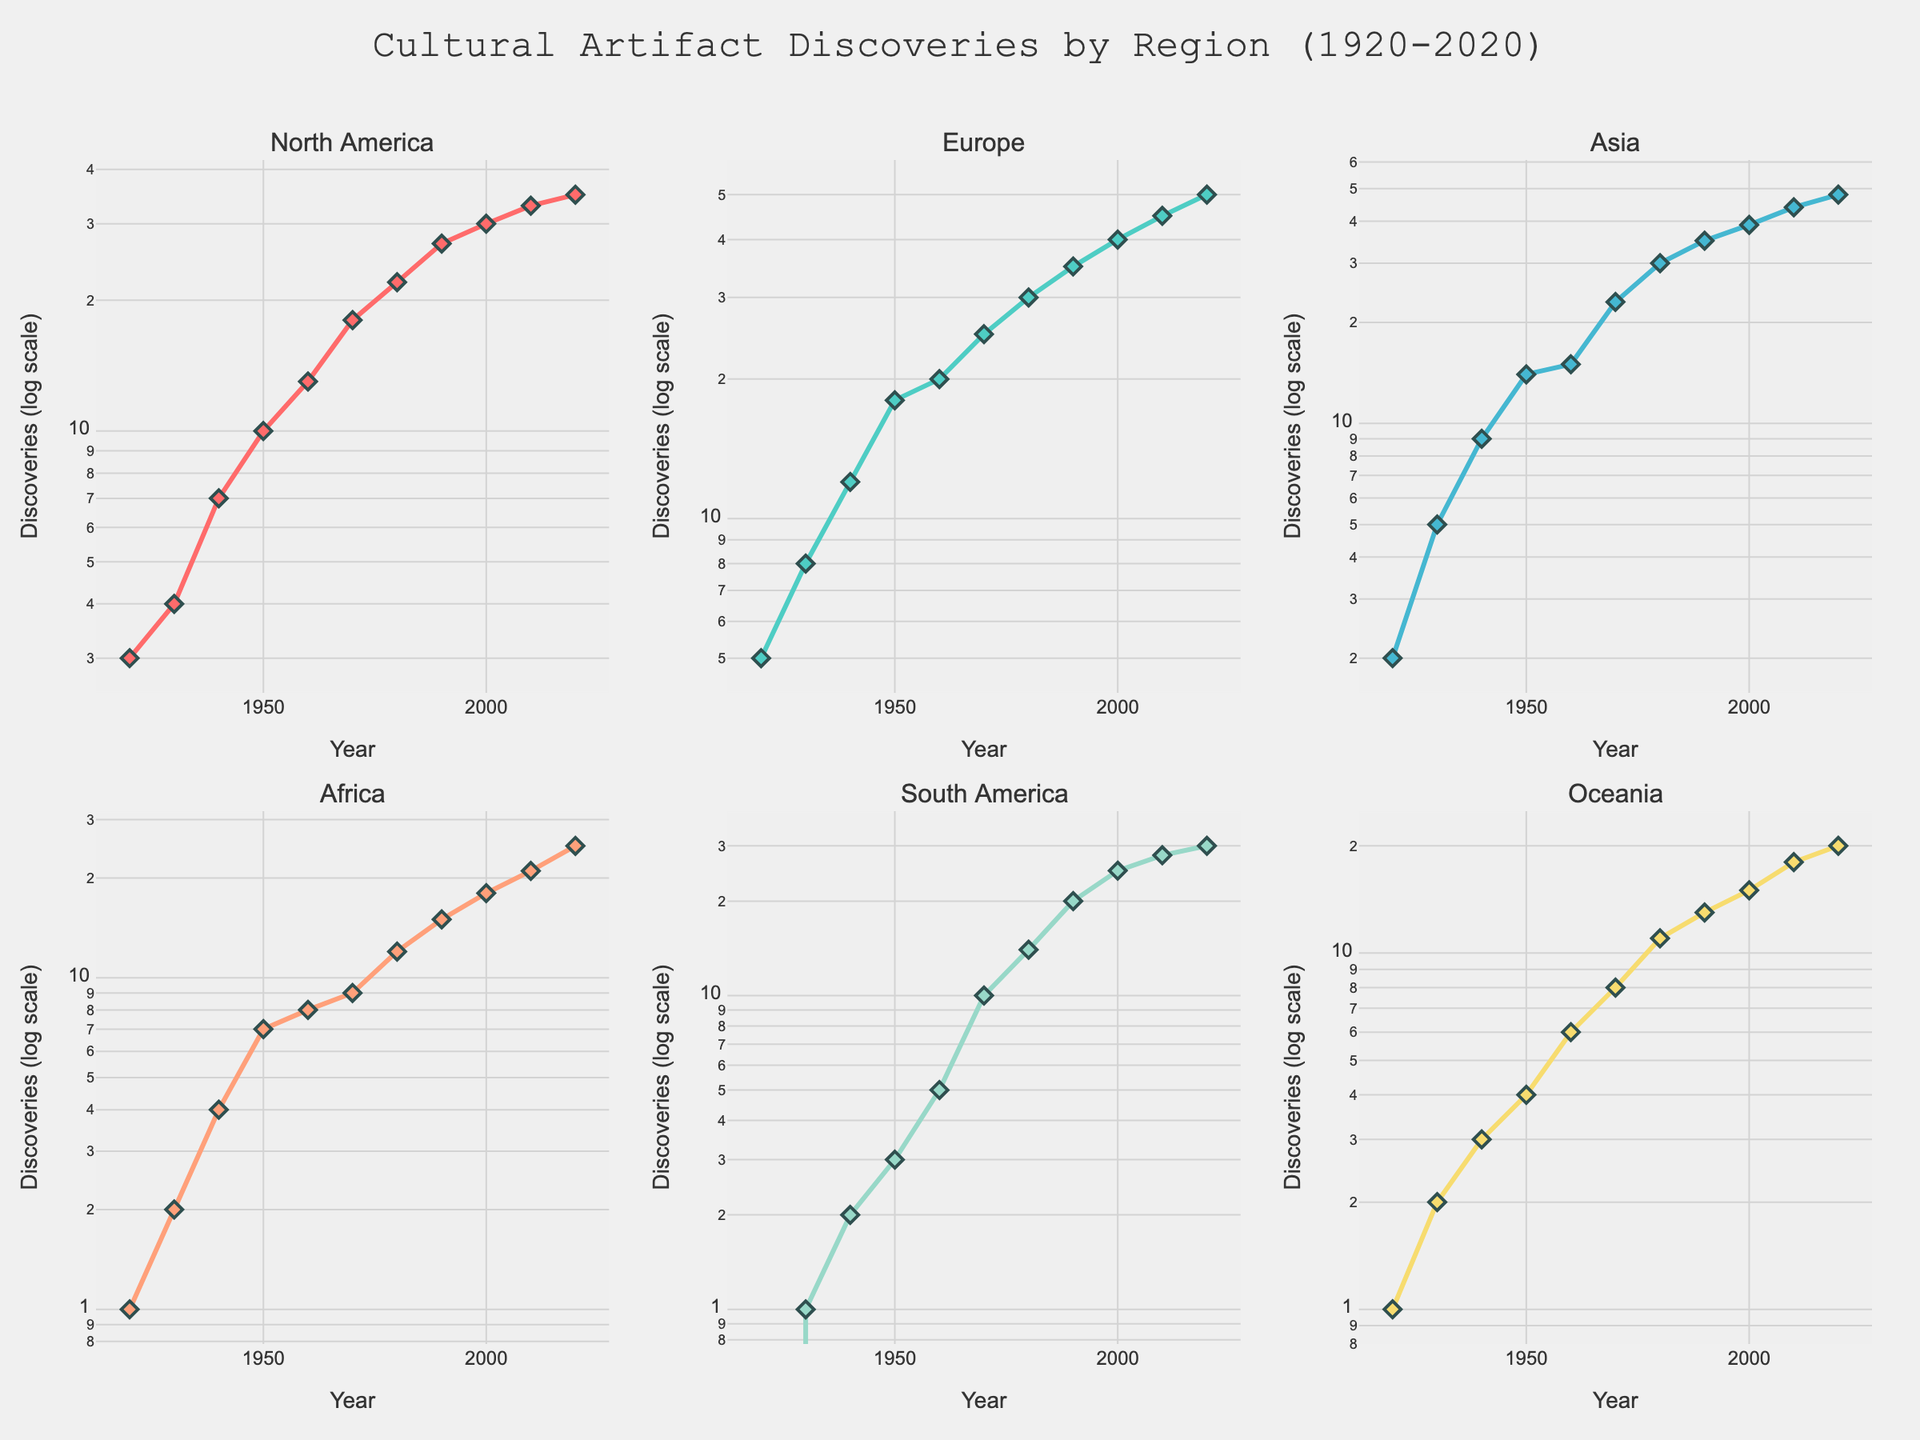Which region has the highest number of discoveries in 2020? Look at the data points for the year 2020 and compare the discovery counts for each region. Europe shows the highest number.
Answer: Europe How many discoveries were made in North America in 1930? Check the 1930 data point for North America in the subplot. The number of discoveries is shown as 4.
Answer: 4 Between which years did Europe see the largest increase in discoveries? Observe the line plot for Europe and identify the largest upward slope. The largest increase appears between 2010 and 2020.
Answer: 2010 and 2020 Is the trend in discoveries for Africa relatively stable compared to other regions? Examine the line plot for Africa; it shows a gentler slope compared to regions like Europe and Asia, suggesting a more stable trend.
Answer: Yes Which region had the least discoveries in 1920? Look at the 1920 data points in each subplot. South America had zero discoveries, which is the least.
Answer: South America How does the number of discoveries in Asia in 1960 compare to that in Oceania in 2020? Compare the data points for Asia in 1960 and Oceania in 2020. Asia had 15 discoveries in 1960, whereas Oceania had 20 in 2020.
Answer: Oceania has more What's the total number of discoveries in all regions in 1940? Add the number of discoveries for each region in 1940 (7 + 12 + 9 + 4 + 2 + 3). The total is 37.
Answer: 37 In which decade did South America make more than 10 discoveries for the first time? Look at the South America subplot and check when the discovery count surpassed 10, which occurs in 1970.
Answer: 1970 Are the discovery trends in Asia and Europe more similar in any specific decades? Compare the subplot lines for Asia and Europe. Both show a steep rise from 1980 to 2020, indicating a similar trend.
Answer: 1980-2020 Which region shows the most fluctuations in its discovery trends? Compare the line trends across all subplots. North America's plot shows frequent peaks and troughs, indicating high fluctuation.
Answer: North America 